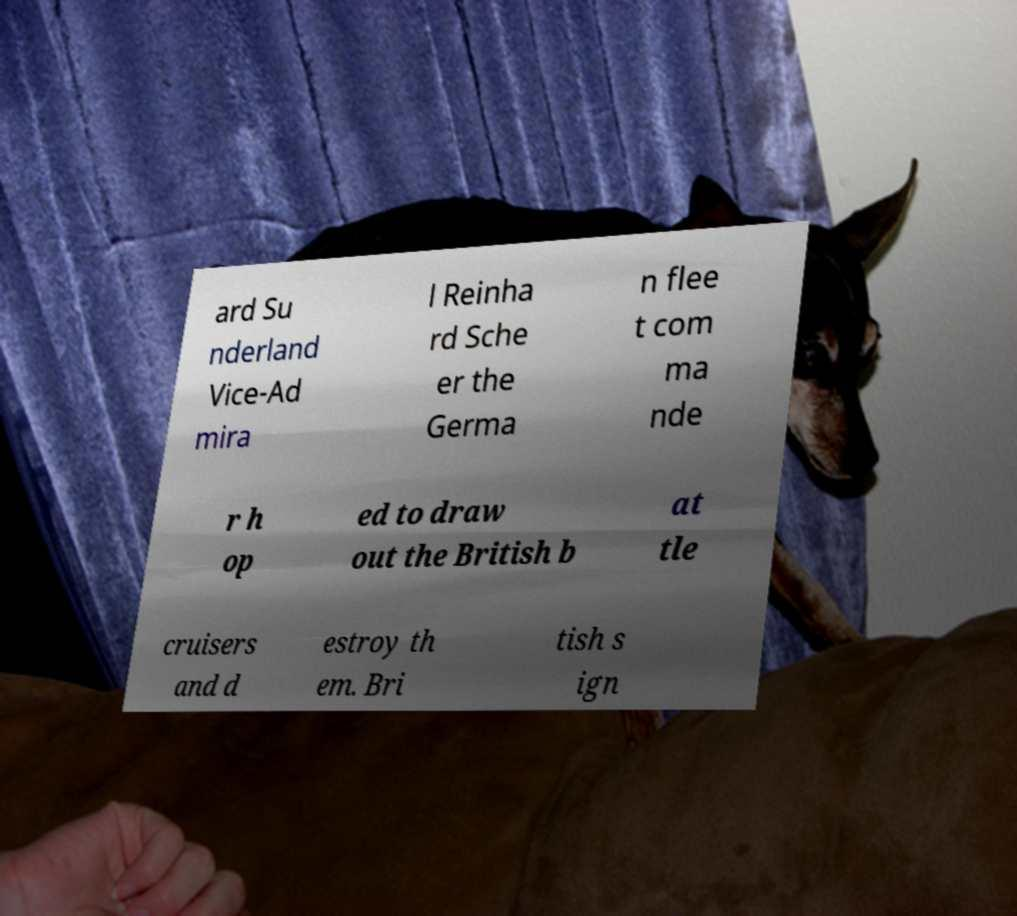What messages or text are displayed in this image? I need them in a readable, typed format. ard Su nderland Vice-Ad mira l Reinha rd Sche er the Germa n flee t com ma nde r h op ed to draw out the British b at tle cruisers and d estroy th em. Bri tish s ign 